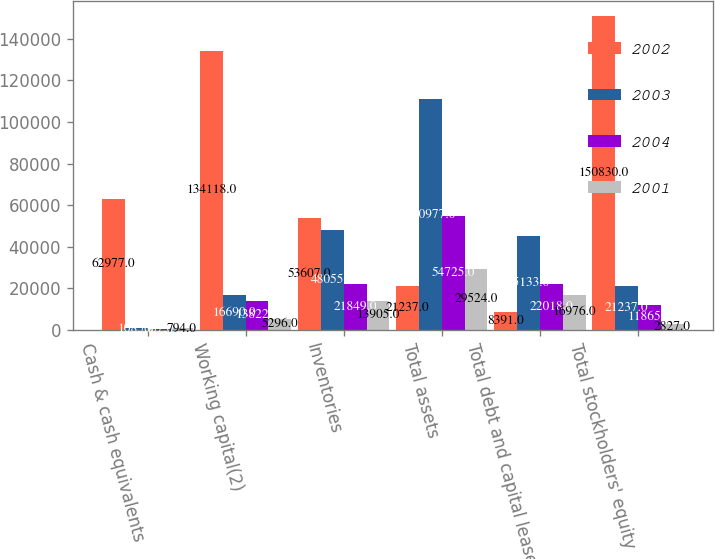<chart> <loc_0><loc_0><loc_500><loc_500><stacked_bar_chart><ecel><fcel>Cash & cash equivalents<fcel>Working capital(2)<fcel>Inventories<fcel>Total assets<fcel>Total debt and capital lease<fcel>Total stockholders' equity<nl><fcel>2002<fcel>62977<fcel>134118<fcel>53607<fcel>21237<fcel>8391<fcel>150830<nl><fcel>2003<fcel>1085<fcel>16690<fcel>48055<fcel>110977<fcel>45133<fcel>21237<nl><fcel>2004<fcel>667<fcel>13822<fcel>21849<fcel>54725<fcel>22018<fcel>11865<nl><fcel>2001<fcel>794<fcel>5296<fcel>13905<fcel>29524<fcel>16976<fcel>2827<nl></chart> 